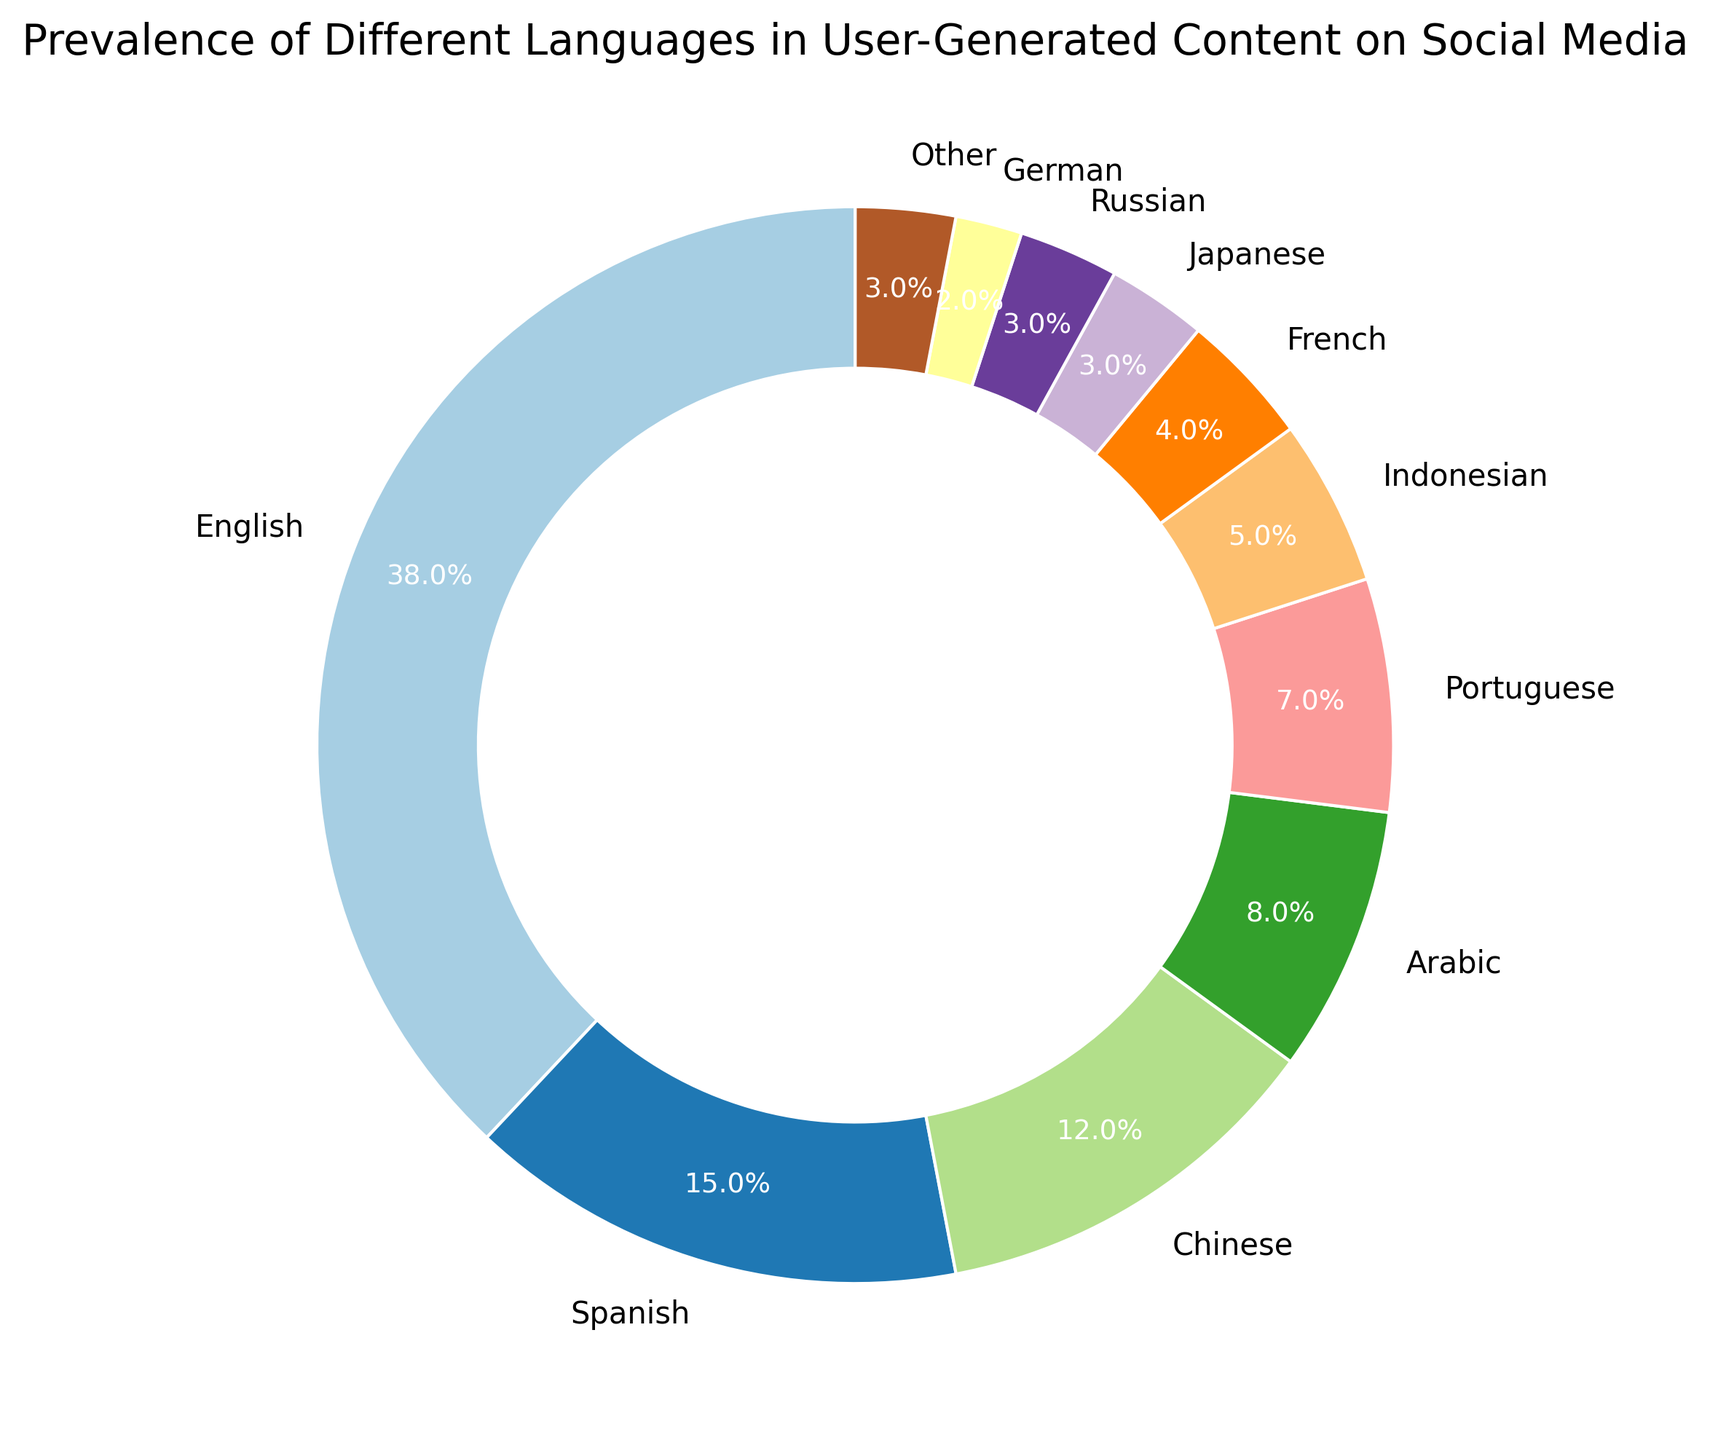What percentage of user-generated content is in English and Spanish combined? To find the combined percentage, add the percentages of content in English (38%) and Spanish (15%). 38 + 15 = 53
Answer: 53% Which language has the third highest prevalence in user-generated content? The languages with the highest, second highest, and third highest prevalences are English (38%), Spanish (15%), and Chinese (12%), respectively.
Answer: Chinese Is the percentage of Portuguese user-generated content higher or lower than that of Arabic? The percentage of Portuguese content is 7%, while that of Arabic is 8%.
Answer: Lower How many languages have a prevalence lower than 5%? The languages with prevalence lower than 5% are French (4%), Japanese (3%), Russian (3%), German (2%), and Other (3%). There are 5 such languages.
Answer: 5 What is the difference between the percentage of English content and the percentage of Chinese content? Subtract the percentage of Chinese content (12%) from the percentage of English content (38%). 38 - 12 = 26
Answer: 26 Which color represents the language with the highest prevalence in user-generated content? The language with the highest prevalence is English, represented by the first segment of the ring chart, colored in a specific shade from the color palette used (usually the first color in the given palette).
Answer: Depends on the palette but typically the first segment color What is the average percentage of user-generated content for the languages Portuguese, Indonesian, and French? To find the average, add the percentages of these languages (Portuguese: 7%, Indonesian: 5%, French: 4%) and then divide by the number of languages. (7 + 5 + 4) / 3 = 16 / 3 ≈ 5.33
Answer: 5.33 Compare the sum of percentages of Arabic and Japanese user-generated content to the percentage of Spanish content. Which sum is higher? Sum the percentages for Arabic (8%) and Japanese (3%), and compare to Spanish (15%). 8 + 3 = 11, which is less than 15.
Answer: Spanish content Which segment in the ring chart is the smallest, and what does it represent? The smallest segment corresponds to a 2% prevalence, representing German.
Answer: German How does the percentage of English content compare to the combined percentage of Indonesian and French content? The percentage of English content is 38%, while the combined percentage of Indonesian (5%) and French (4%) is 9%. 38% is significantly higher than 9%.
Answer: Higher 